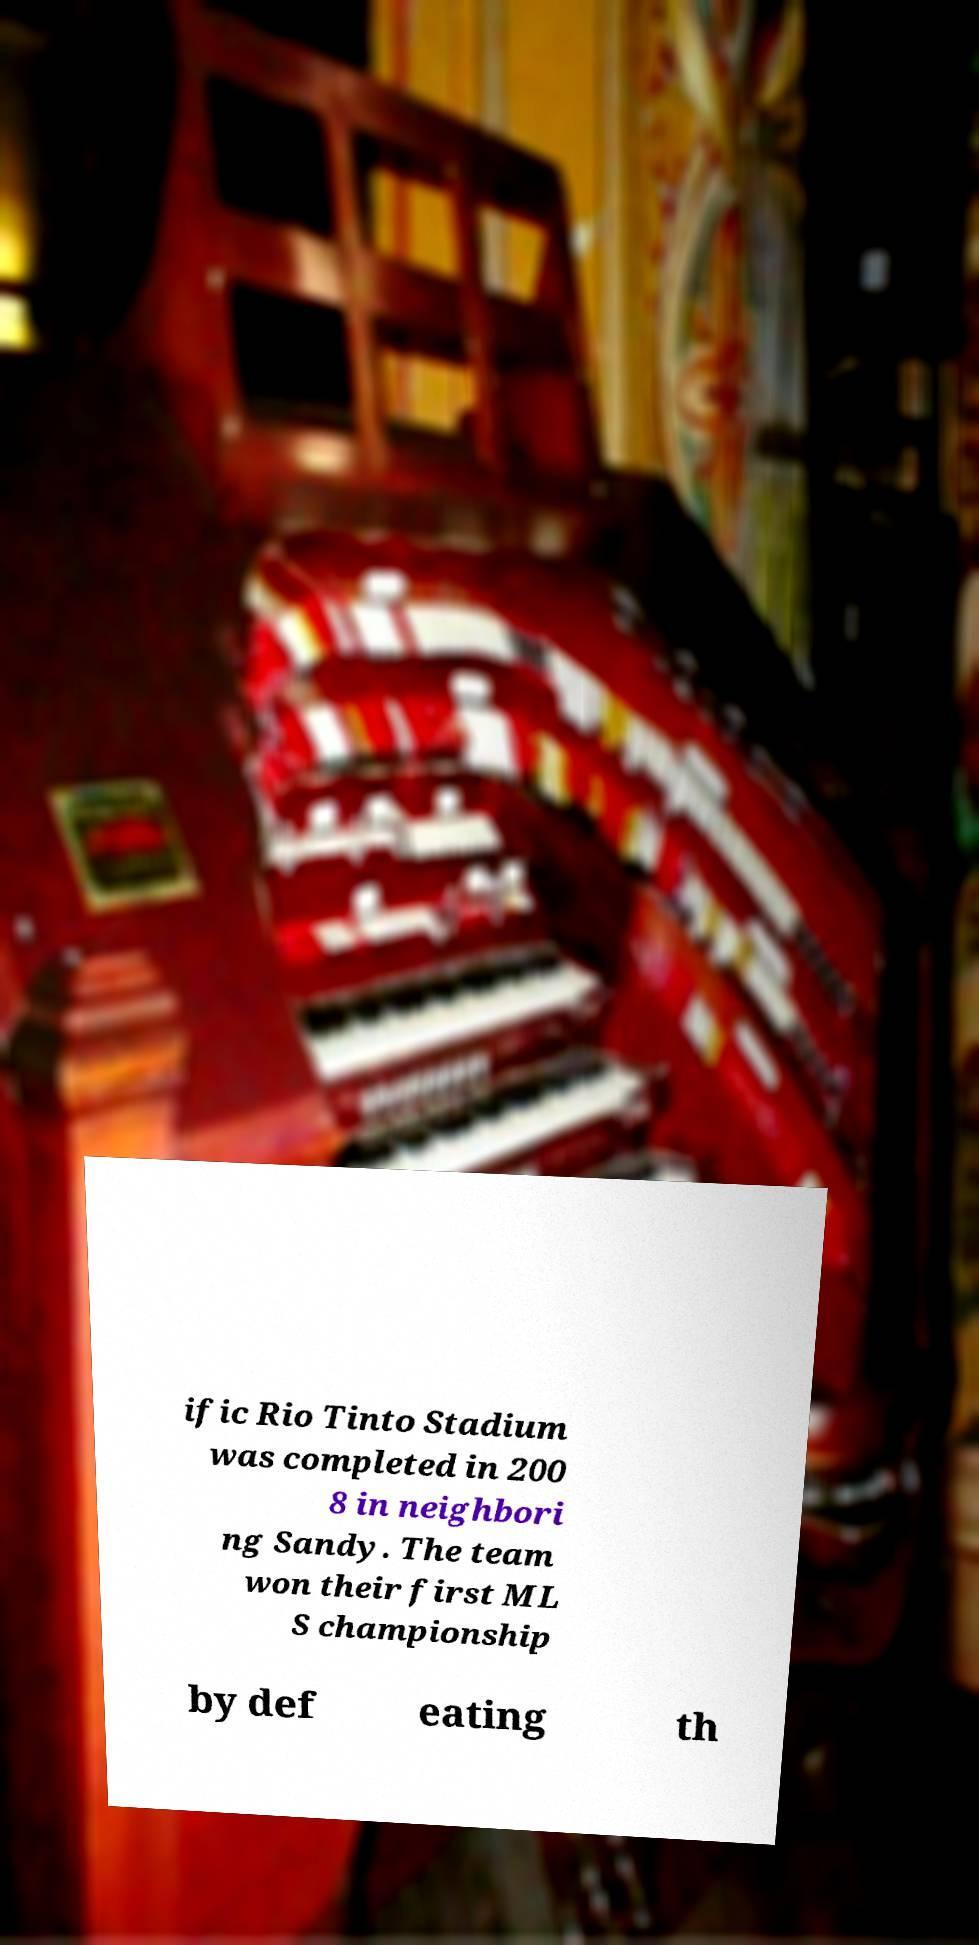Can you accurately transcribe the text from the provided image for me? ific Rio Tinto Stadium was completed in 200 8 in neighbori ng Sandy. The team won their first ML S championship by def eating th 